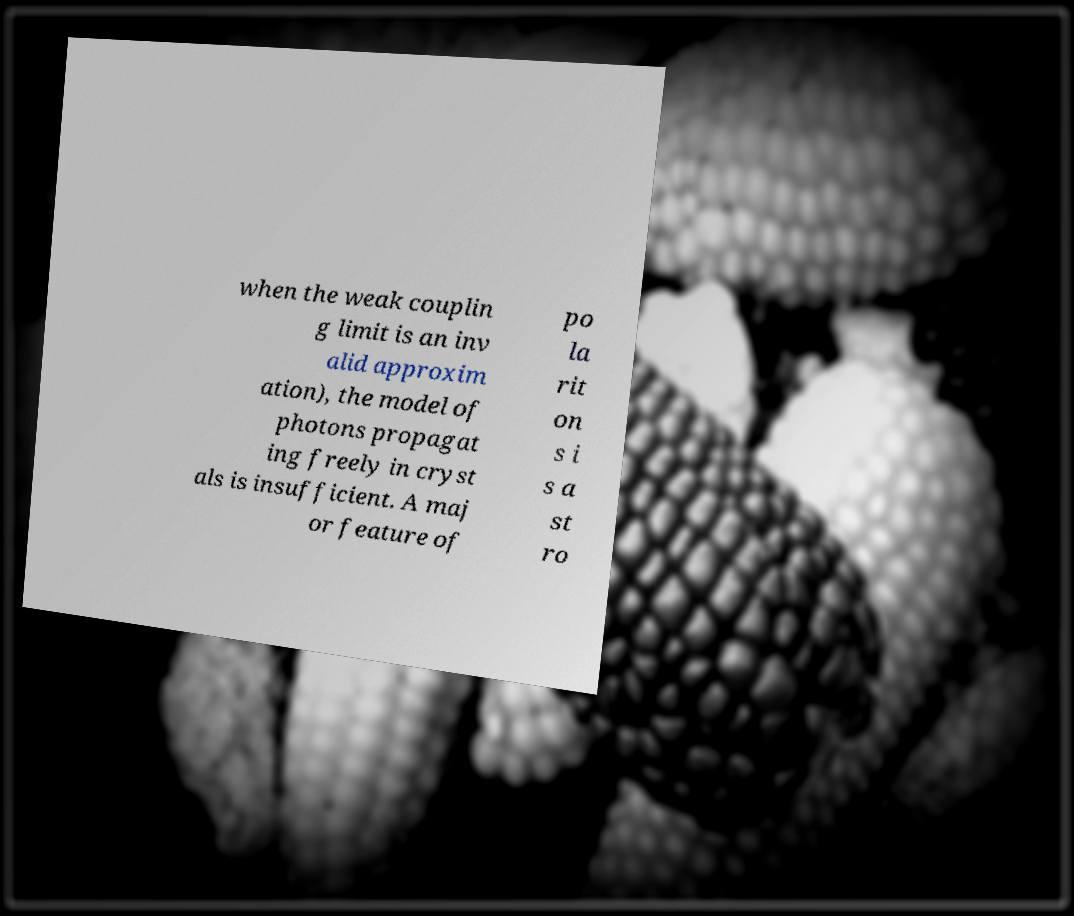Can you read and provide the text displayed in the image?This photo seems to have some interesting text. Can you extract and type it out for me? when the weak couplin g limit is an inv alid approxim ation), the model of photons propagat ing freely in cryst als is insufficient. A maj or feature of po la rit on s i s a st ro 